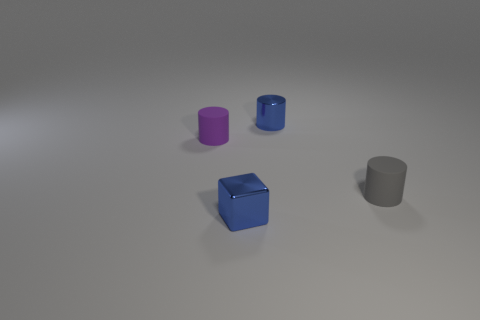Add 4 small matte things. How many objects exist? 8 Subtract all cylinders. How many objects are left? 1 Subtract 0 yellow spheres. How many objects are left? 4 Subtract all big shiny things. Subtract all tiny purple objects. How many objects are left? 3 Add 3 blue cubes. How many blue cubes are left? 4 Add 4 blue shiny cubes. How many blue shiny cubes exist? 5 